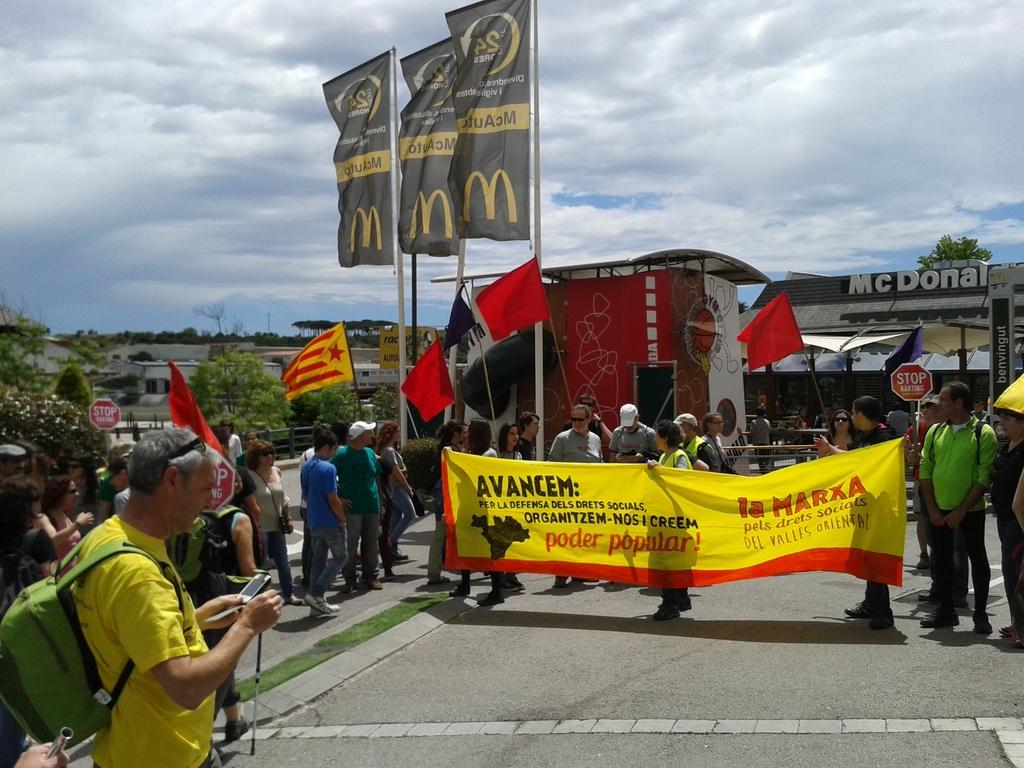What street sign is seen in the background?
Give a very brief answer. Stop. What restaurant is on strike?
Your answer should be very brief. Mcdonalds. 